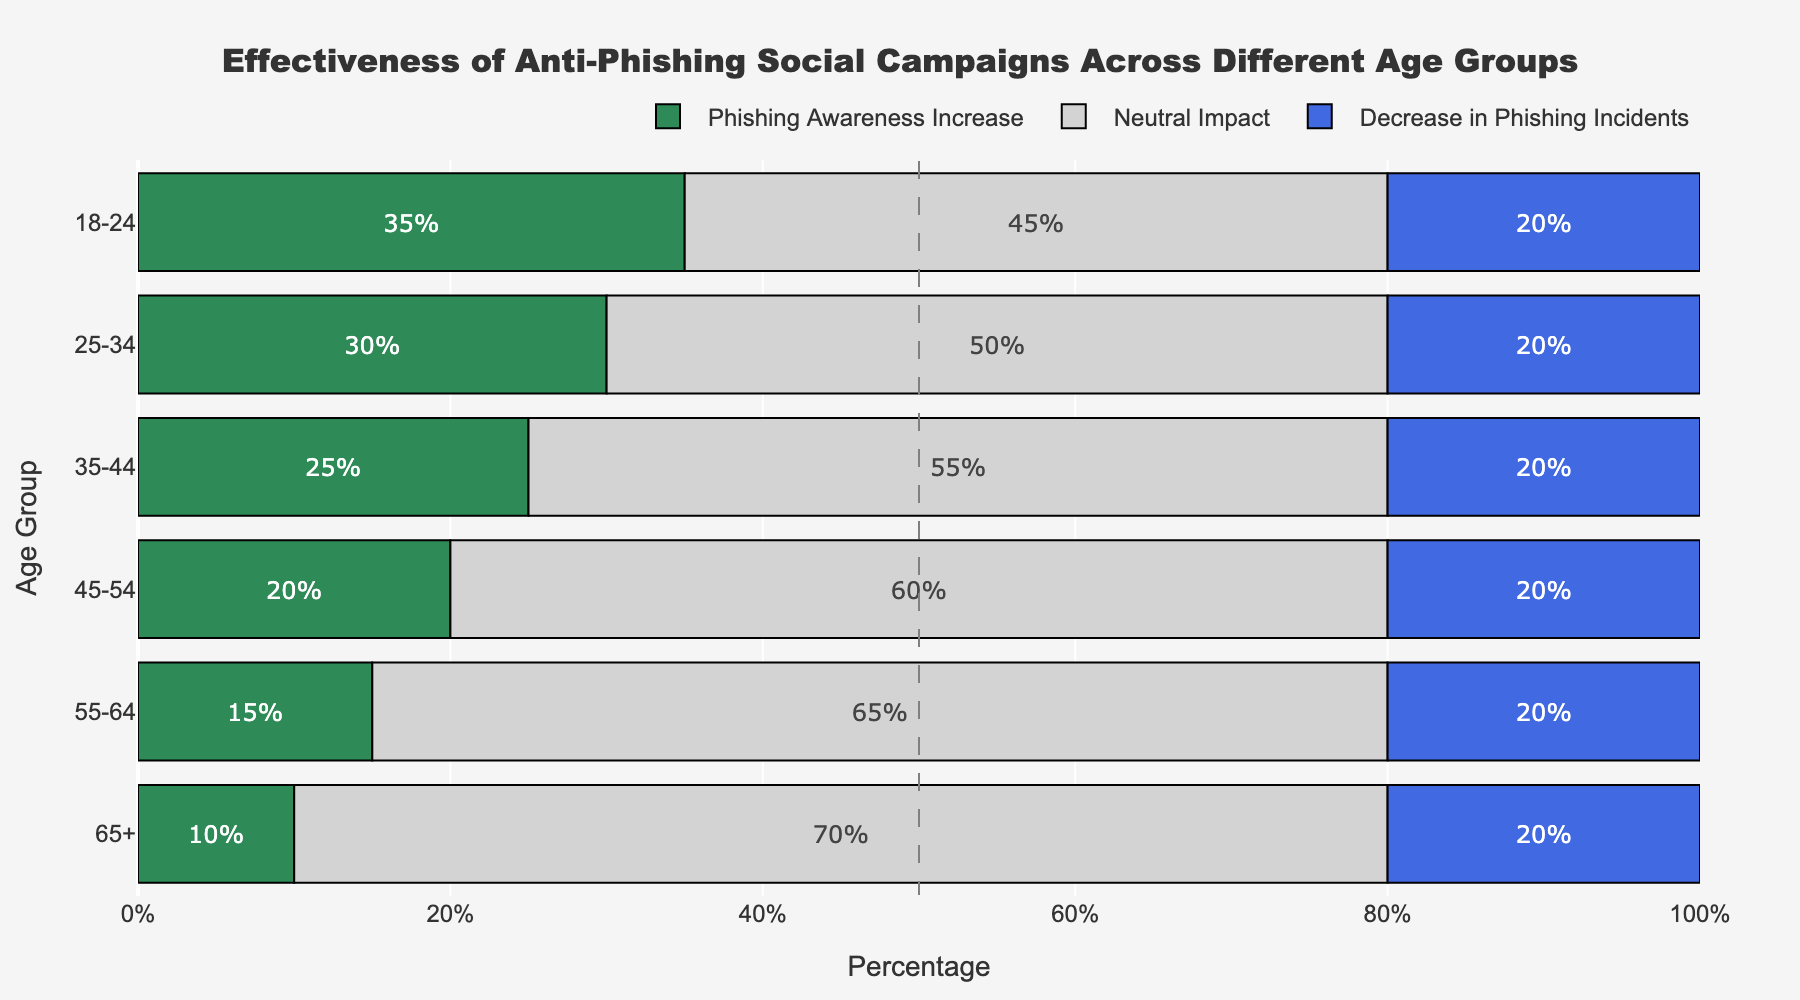What age group shows the highest percentage of neutral impact from the anti-phishing campaigns? Looking at the chart, the bars indicate that the 65+ age group has the highest percentage of neutral impact at 70%.
Answer: 65+ Which age group has the least increase in phishing awareness? By comparing the green bars across age groups, the 65+ age group has the shortest bar with an increase of 10%.
Answer: 65+ How many age groups have a decrease in phishing incidents of 20%? From the blue bars, all age groups have a decrease in phishing incidents of 20%. There are 6 age groups in total.
Answer: 6 What is the difference in percentages between the highest increase in phishing awareness and the lowest increase in phishing awareness? The highest increase is 35% (18-24 age group) and the lowest increase is 10% (65+ age group). The difference is 35% - 10% = 25%.
Answer: 25% Compare the neutral impact between the age groups 18-24 and 55-64. Which one has a higher percentage? The 55-64 age group has a neutral impact percentage of 65%, while the 18-24 age group has a neutral impact percentage of 45%. Therefore, the 55-64 age group has a higher percentage.
Answer: 55-64 What is the total percentage for the decrease in phishing incidents across all age groups? Each age group has a 20% decrease. Adding them up: 20% * 6 = 120%.
Answer: 120% In the 35-44 age group, what is the combined percentage of neutral impact and decrease in phishing incidents? Adding the neutral impact (55%) and the decrease in phishing incidents (20%) gives 55% + 20% = 75%.
Answer: 75% What is the average increase in phishing awareness across all age groups? Adding up the percentages of increase (35 + 30 + 25 + 20 + 15 + 10) and dividing by the number of groups (6) gives: (35 + 30 + 25 + 20 + 15 + 10) / 6 = 22.5%.
Answer: 22.5% 